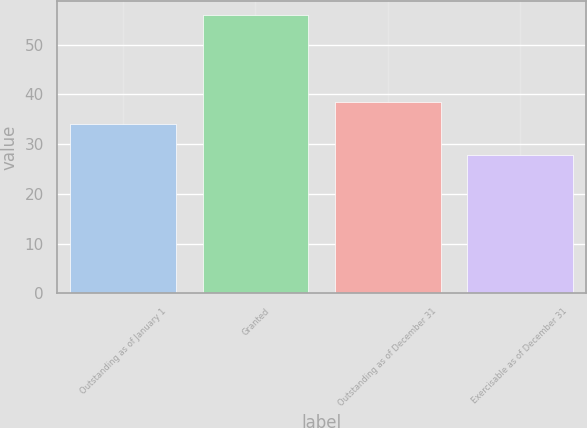Convert chart. <chart><loc_0><loc_0><loc_500><loc_500><bar_chart><fcel>Outstanding as of January 1<fcel>Granted<fcel>Outstanding as of December 31<fcel>Exercisable as of December 31<nl><fcel>34.06<fcel>56<fcel>38.52<fcel>27.89<nl></chart> 